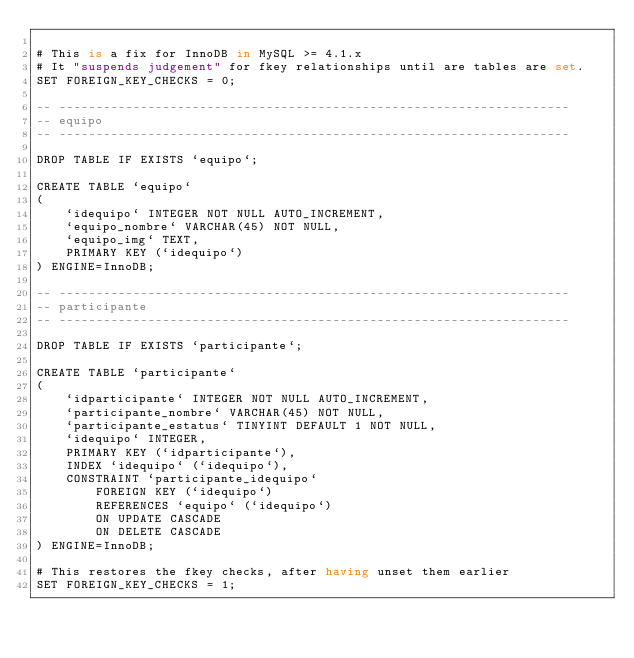Convert code to text. <code><loc_0><loc_0><loc_500><loc_500><_SQL_>
# This is a fix for InnoDB in MySQL >= 4.1.x
# It "suspends judgement" for fkey relationships until are tables are set.
SET FOREIGN_KEY_CHECKS = 0;

-- ---------------------------------------------------------------------
-- equipo
-- ---------------------------------------------------------------------

DROP TABLE IF EXISTS `equipo`;

CREATE TABLE `equipo`
(
    `idequipo` INTEGER NOT NULL AUTO_INCREMENT,
    `equipo_nombre` VARCHAR(45) NOT NULL,
    `equipo_img` TEXT,
    PRIMARY KEY (`idequipo`)
) ENGINE=InnoDB;

-- ---------------------------------------------------------------------
-- participante
-- ---------------------------------------------------------------------

DROP TABLE IF EXISTS `participante`;

CREATE TABLE `participante`
(
    `idparticipante` INTEGER NOT NULL AUTO_INCREMENT,
    `participante_nombre` VARCHAR(45) NOT NULL,
    `participante_estatus` TINYINT DEFAULT 1 NOT NULL,
    `idequipo` INTEGER,
    PRIMARY KEY (`idparticipante`),
    INDEX `idequipo` (`idequipo`),
    CONSTRAINT `participante_idequipo`
        FOREIGN KEY (`idequipo`)
        REFERENCES `equipo` (`idequipo`)
        ON UPDATE CASCADE
        ON DELETE CASCADE
) ENGINE=InnoDB;

# This restores the fkey checks, after having unset them earlier
SET FOREIGN_KEY_CHECKS = 1;
</code> 